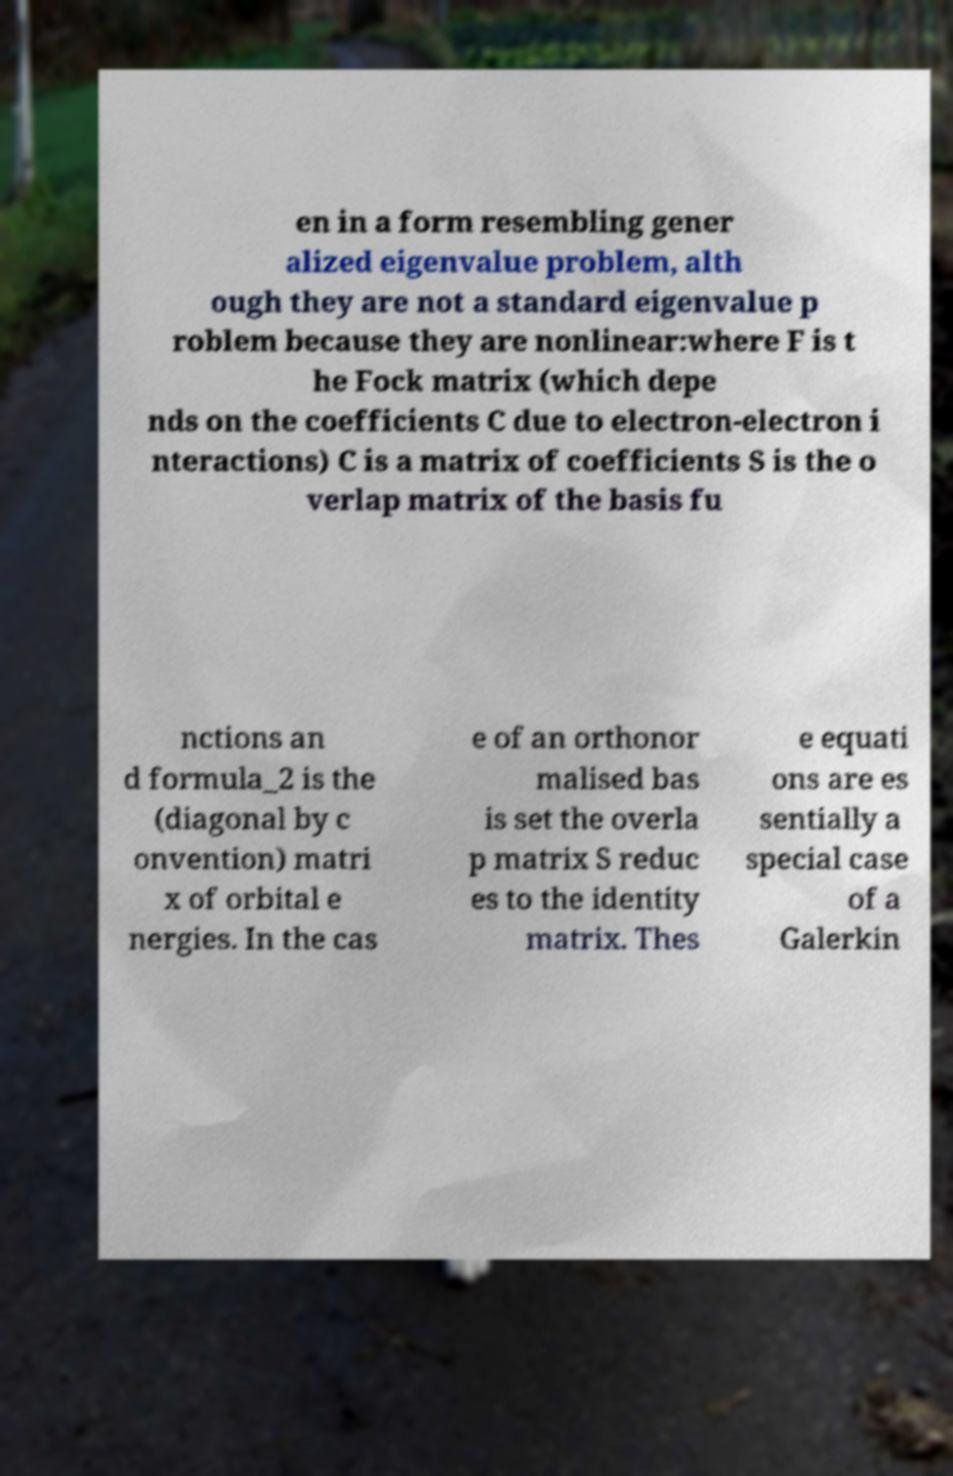Can you read and provide the text displayed in the image?This photo seems to have some interesting text. Can you extract and type it out for me? en in a form resembling gener alized eigenvalue problem, alth ough they are not a standard eigenvalue p roblem because they are nonlinear:where F is t he Fock matrix (which depe nds on the coefficients C due to electron-electron i nteractions) C is a matrix of coefficients S is the o verlap matrix of the basis fu nctions an d formula_2 is the (diagonal by c onvention) matri x of orbital e nergies. In the cas e of an orthonor malised bas is set the overla p matrix S reduc es to the identity matrix. Thes e equati ons are es sentially a special case of a Galerkin 